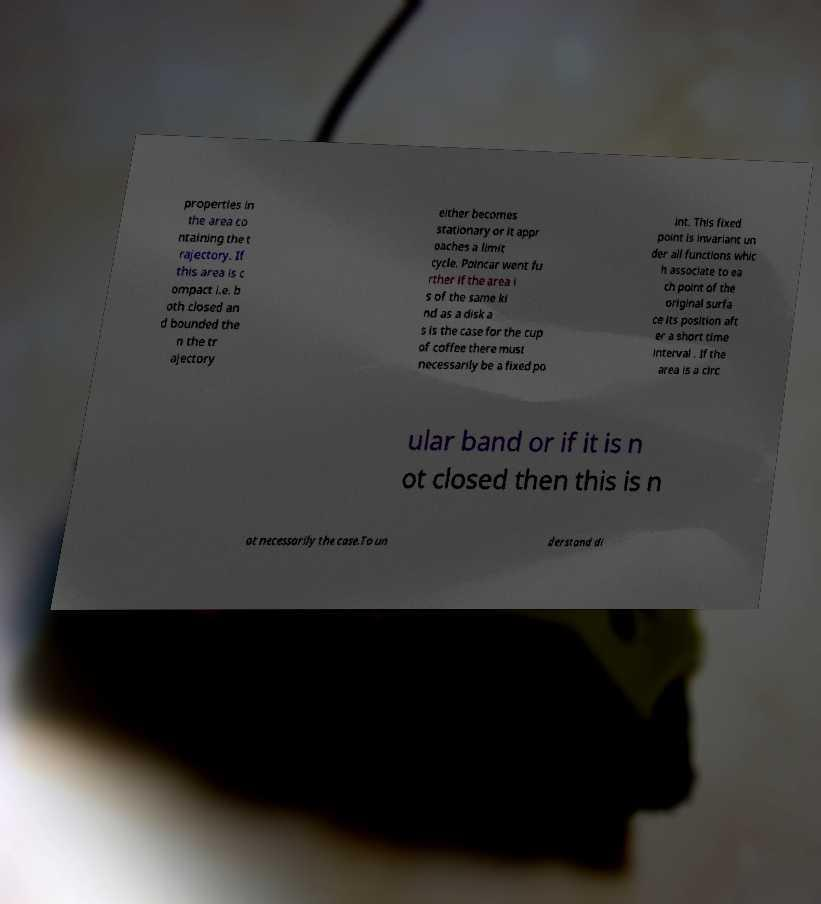Could you extract and type out the text from this image? properties in the area co ntaining the t rajectory. If this area is c ompact i.e. b oth closed an d bounded the n the tr ajectory either becomes stationary or it appr oaches a limit cycle. Poincar went fu rther if the area i s of the same ki nd as a disk a s is the case for the cup of coffee there must necessarily be a fixed po int. This fixed point is invariant un der all functions whic h associate to ea ch point of the original surfa ce its position aft er a short time interval . If the area is a circ ular band or if it is n ot closed then this is n ot necessarily the case.To un derstand di 